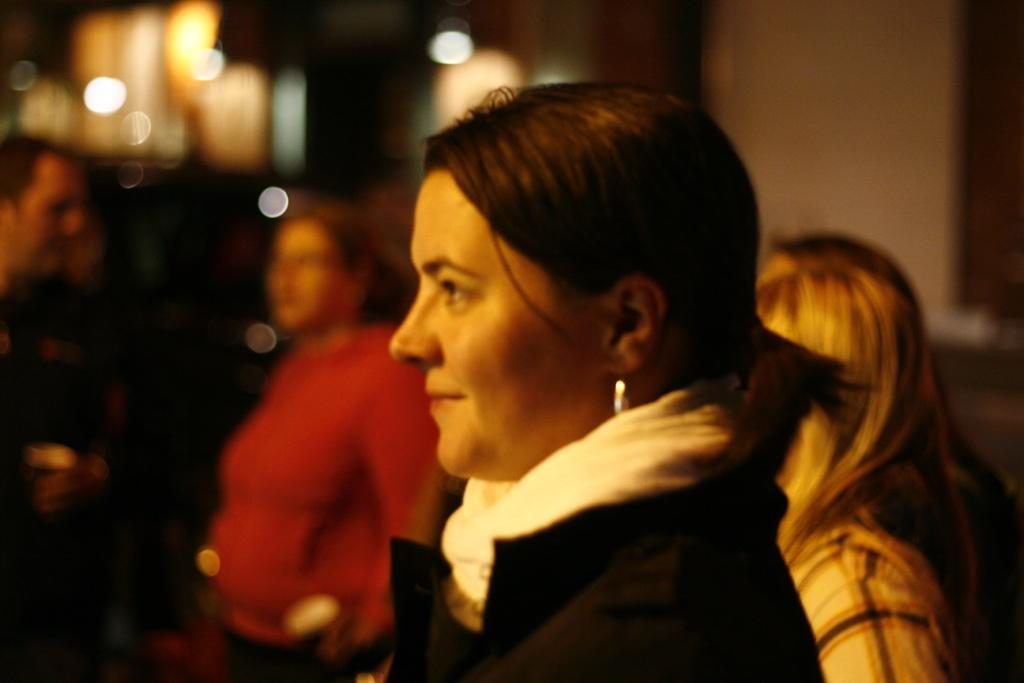How many people are in the image? There are people in the image, but the exact number is not specified. Can you describe the clothing of one of the people? One person is wearing a black and white dress. What can be said about the background of the image? The background of the image is blurred. What type of brush is being used by the person in the image? There is no brush visible in the image. What religious beliefs are being practiced by the people in the image? The facts provided do not give any information about the religious beliefs of the people in the image. 